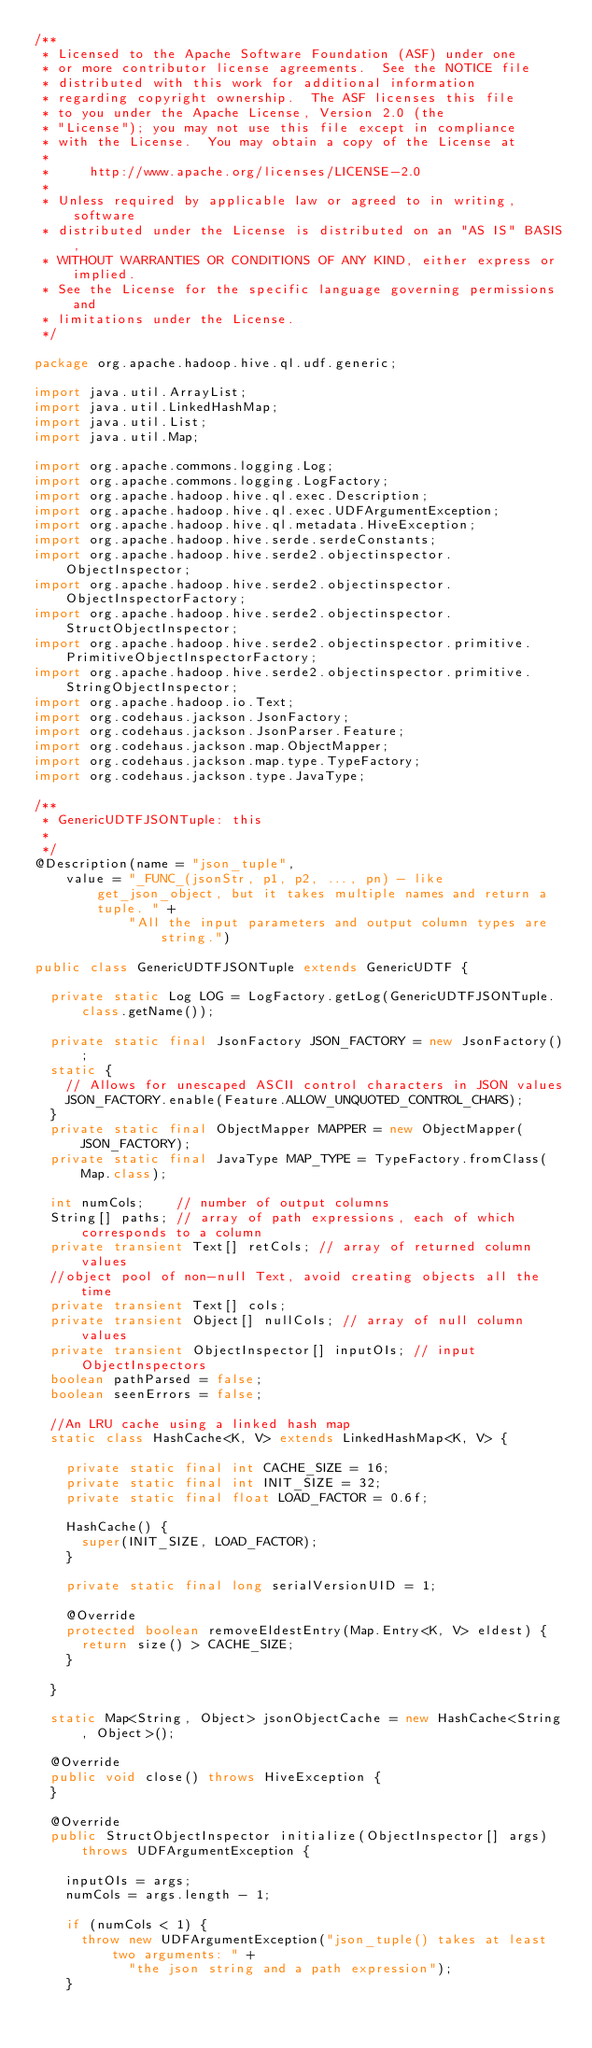<code> <loc_0><loc_0><loc_500><loc_500><_Java_>/**
 * Licensed to the Apache Software Foundation (ASF) under one
 * or more contributor license agreements.  See the NOTICE file
 * distributed with this work for additional information
 * regarding copyright ownership.  The ASF licenses this file
 * to you under the Apache License, Version 2.0 (the
 * "License"); you may not use this file except in compliance
 * with the License.  You may obtain a copy of the License at
 *
 *     http://www.apache.org/licenses/LICENSE-2.0
 *
 * Unless required by applicable law or agreed to in writing, software
 * distributed under the License is distributed on an "AS IS" BASIS,
 * WITHOUT WARRANTIES OR CONDITIONS OF ANY KIND, either express or implied.
 * See the License for the specific language governing permissions and
 * limitations under the License.
 */

package org.apache.hadoop.hive.ql.udf.generic;

import java.util.ArrayList;
import java.util.LinkedHashMap;
import java.util.List;
import java.util.Map;

import org.apache.commons.logging.Log;
import org.apache.commons.logging.LogFactory;
import org.apache.hadoop.hive.ql.exec.Description;
import org.apache.hadoop.hive.ql.exec.UDFArgumentException;
import org.apache.hadoop.hive.ql.metadata.HiveException;
import org.apache.hadoop.hive.serde.serdeConstants;
import org.apache.hadoop.hive.serde2.objectinspector.ObjectInspector;
import org.apache.hadoop.hive.serde2.objectinspector.ObjectInspectorFactory;
import org.apache.hadoop.hive.serde2.objectinspector.StructObjectInspector;
import org.apache.hadoop.hive.serde2.objectinspector.primitive.PrimitiveObjectInspectorFactory;
import org.apache.hadoop.hive.serde2.objectinspector.primitive.StringObjectInspector;
import org.apache.hadoop.io.Text;
import org.codehaus.jackson.JsonFactory;
import org.codehaus.jackson.JsonParser.Feature;
import org.codehaus.jackson.map.ObjectMapper;
import org.codehaus.jackson.map.type.TypeFactory;
import org.codehaus.jackson.type.JavaType;

/**
 * GenericUDTFJSONTuple: this
 *
 */
@Description(name = "json_tuple",
    value = "_FUNC_(jsonStr, p1, p2, ..., pn) - like get_json_object, but it takes multiple names and return a tuple. " +
    		"All the input parameters and output column types are string.")

public class GenericUDTFJSONTuple extends GenericUDTF {

  private static Log LOG = LogFactory.getLog(GenericUDTFJSONTuple.class.getName());

  private static final JsonFactory JSON_FACTORY = new JsonFactory();
  static {
    // Allows for unescaped ASCII control characters in JSON values
    JSON_FACTORY.enable(Feature.ALLOW_UNQUOTED_CONTROL_CHARS);
  }
  private static final ObjectMapper MAPPER = new ObjectMapper(JSON_FACTORY);
  private static final JavaType MAP_TYPE = TypeFactory.fromClass(Map.class);

  int numCols;    // number of output columns
  String[] paths; // array of path expressions, each of which corresponds to a column
  private transient Text[] retCols; // array of returned column values
  //object pool of non-null Text, avoid creating objects all the time
  private transient Text[] cols;
  private transient Object[] nullCols; // array of null column values
  private transient ObjectInspector[] inputOIs; // input ObjectInspectors
  boolean pathParsed = false;
  boolean seenErrors = false;

  //An LRU cache using a linked hash map
  static class HashCache<K, V> extends LinkedHashMap<K, V> {

    private static final int CACHE_SIZE = 16;
    private static final int INIT_SIZE = 32;
    private static final float LOAD_FACTOR = 0.6f;

    HashCache() {
      super(INIT_SIZE, LOAD_FACTOR);
    }

    private static final long serialVersionUID = 1;

    @Override
    protected boolean removeEldestEntry(Map.Entry<K, V> eldest) {
      return size() > CACHE_SIZE;
    }

  }

  static Map<String, Object> jsonObjectCache = new HashCache<String, Object>();

  @Override
  public void close() throws HiveException {
  }

  @Override
  public StructObjectInspector initialize(ObjectInspector[] args)
      throws UDFArgumentException {

    inputOIs = args;
    numCols = args.length - 1;

    if (numCols < 1) {
      throw new UDFArgumentException("json_tuple() takes at least two arguments: " +
      		"the json string and a path expression");
    }
</code> 